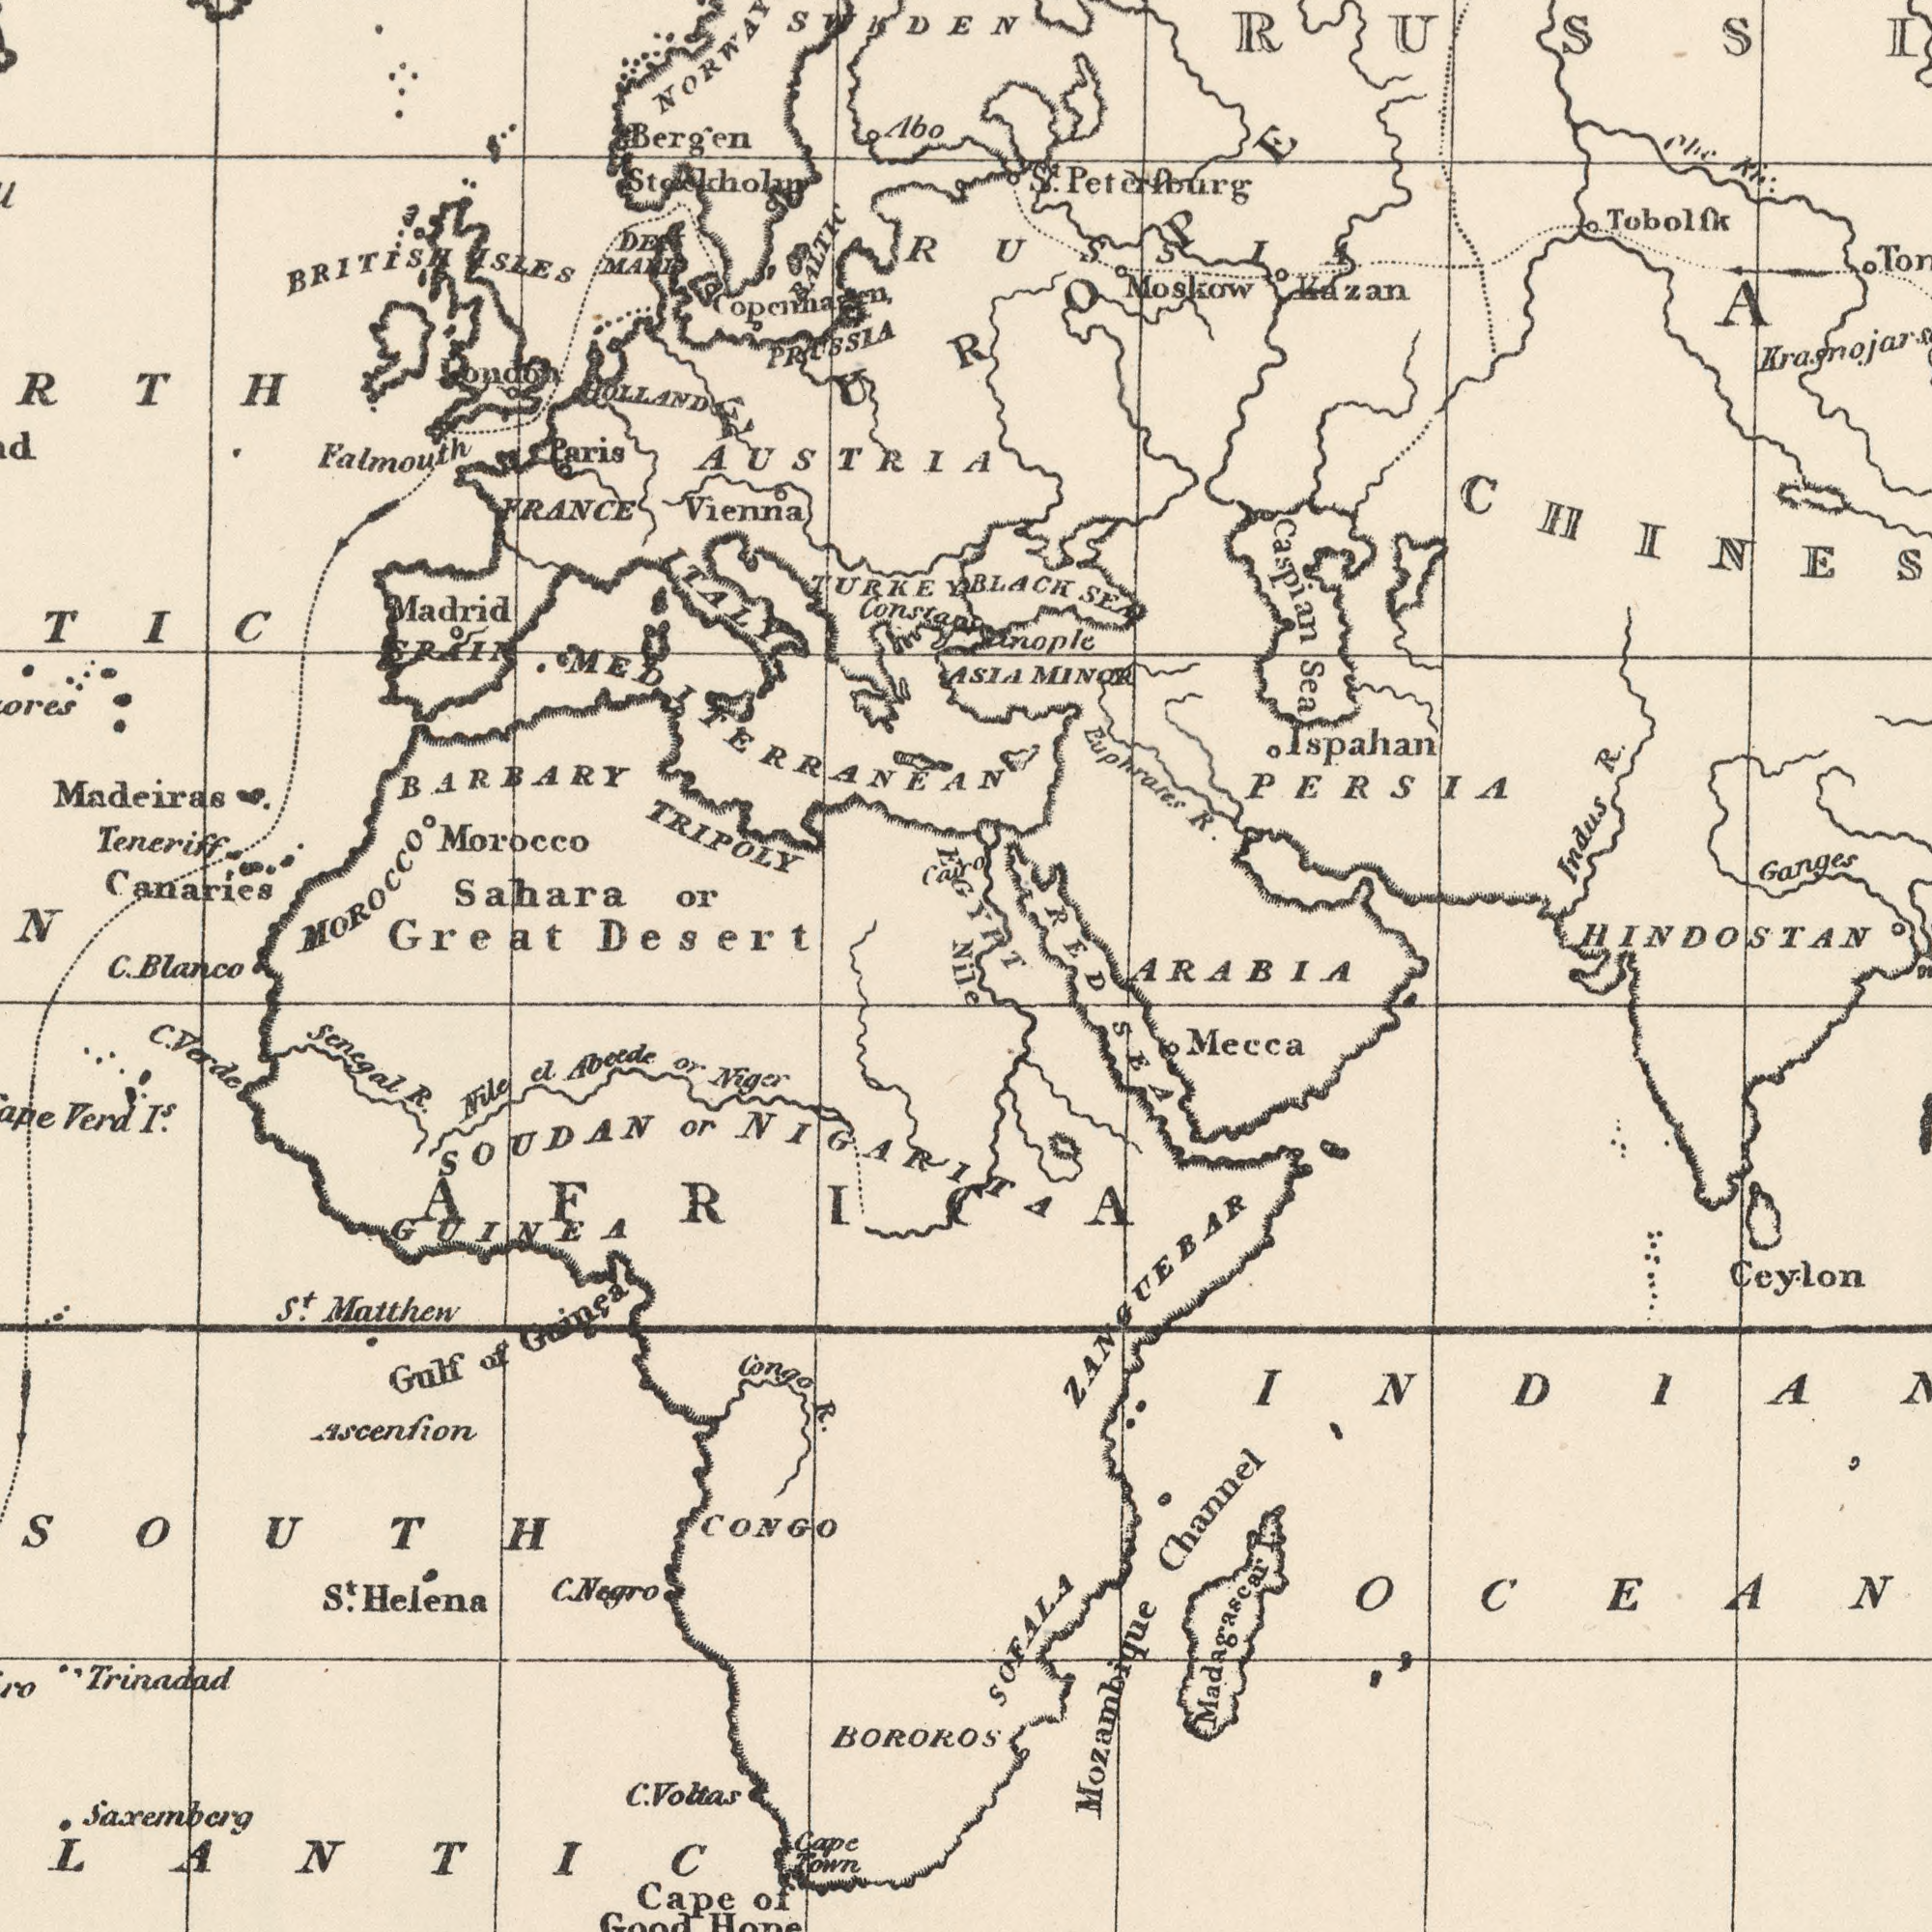What text is visible in the upper-left corner? BARBARY TRIPOLY Sahara or Great Desert AUSTRIA FRANCE Falmouth MOROCCO Teneriff Canaries Bergen BRITISH ###N Vienna SWEDEN ITALY Madeiras Madrid PROSSLA ISLES Abo TURKEY Morocco SPAIN Paris OOLLAND London MEDITERRANEAN ###RTH Cairo BALTIC ###TIC Stockholm C. Blanco What text is shown in the bottom-left quadrant? Senegal R. Congo R. Trinadad CONGO St. Helena Nile el Abeede or Niger BOROROS Verd IS . C. Voltas Gulf of Guinea Cape Town Cape of Good Hope SOUTH ###LANTIC St. Matthew Ascenfion GUINEA C. Negro Saxemberg C. Vorde AFRICA SOUDAN or NIGARITA What text is visible in the lower-right corner? SEA Ceylon Mozambique Channel Madagascar OCEAN ZANGUEBAR Mecca SOFALA ARABIA Nile What text is shown in the top-right quadrant? BLACK SEA Constantinople PERSIA ASIA MINOR HINDOSTAN Ganges Tobolfk Caspian Sea Moskow Euphrates R. St. Peterfourg Indus R. Kazan Ispahan RED EGYPT EUROPE RUSSIA 